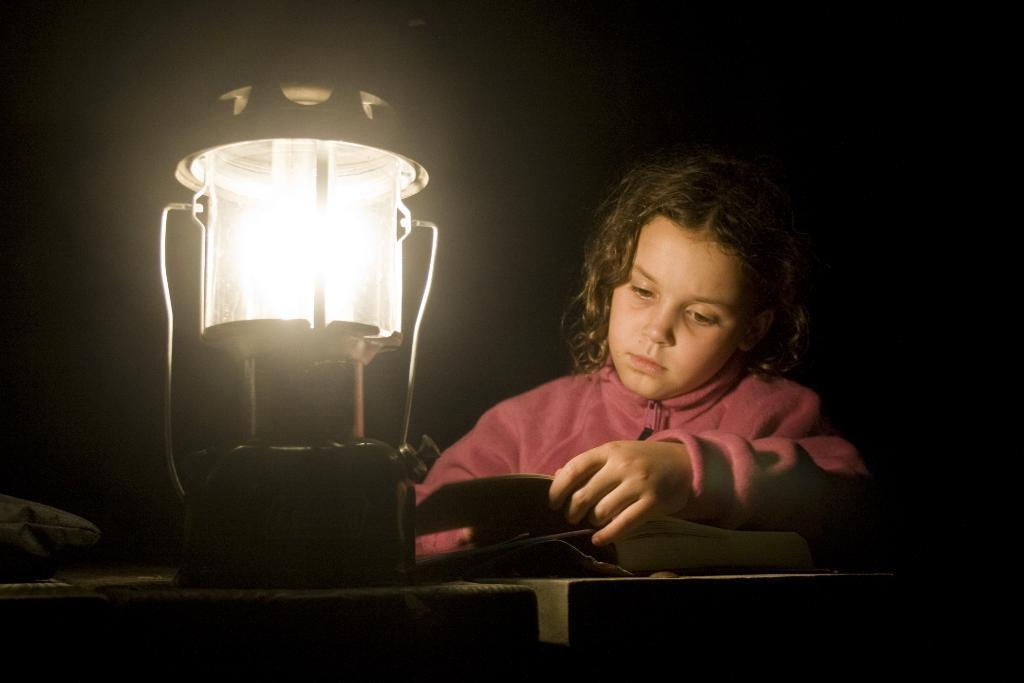What is the main object on the table in the image? There is a lamp on a table in the image. What else can be seen on the table besides the lamp? Other objects are present on the table. Where is the kid located in the image? The kid is on the right side of the image. How would you describe the lighting in the image? The background is dark in the image. How many eyes can be seen on the ducks in the image? There are no ducks present in the image, so the number of eyes on any ducks cannot be determined. 